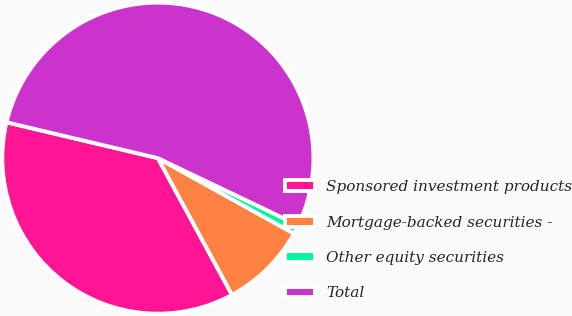<chart> <loc_0><loc_0><loc_500><loc_500><pie_chart><fcel>Sponsored investment products<fcel>Mortgage-backed securities -<fcel>Other equity securities<fcel>Total<nl><fcel>36.61%<fcel>9.04%<fcel>0.96%<fcel>53.39%<nl></chart> 